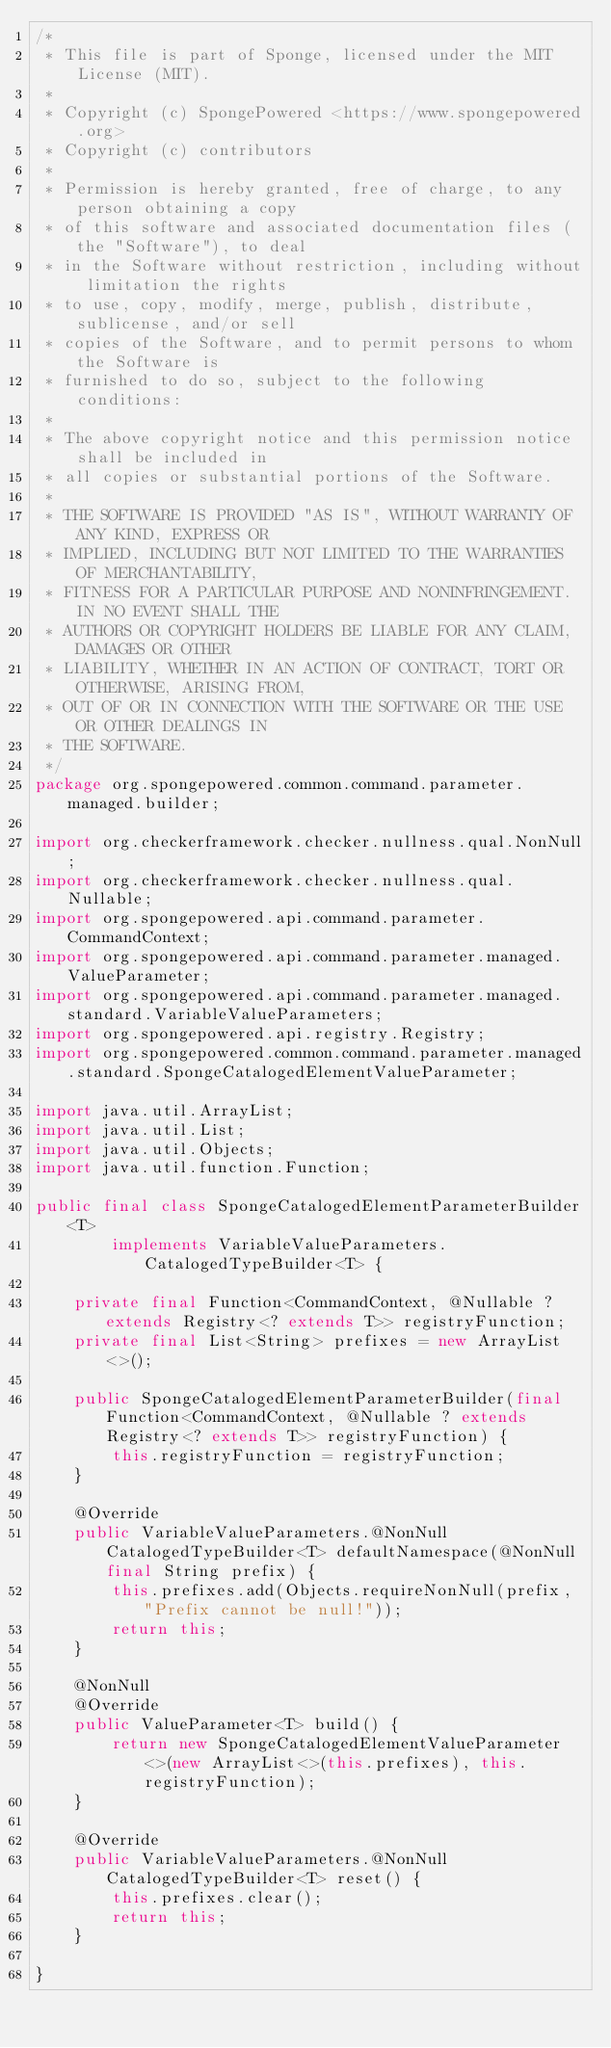<code> <loc_0><loc_0><loc_500><loc_500><_Java_>/*
 * This file is part of Sponge, licensed under the MIT License (MIT).
 *
 * Copyright (c) SpongePowered <https://www.spongepowered.org>
 * Copyright (c) contributors
 *
 * Permission is hereby granted, free of charge, to any person obtaining a copy
 * of this software and associated documentation files (the "Software"), to deal
 * in the Software without restriction, including without limitation the rights
 * to use, copy, modify, merge, publish, distribute, sublicense, and/or sell
 * copies of the Software, and to permit persons to whom the Software is
 * furnished to do so, subject to the following conditions:
 *
 * The above copyright notice and this permission notice shall be included in
 * all copies or substantial portions of the Software.
 *
 * THE SOFTWARE IS PROVIDED "AS IS", WITHOUT WARRANTY OF ANY KIND, EXPRESS OR
 * IMPLIED, INCLUDING BUT NOT LIMITED TO THE WARRANTIES OF MERCHANTABILITY,
 * FITNESS FOR A PARTICULAR PURPOSE AND NONINFRINGEMENT. IN NO EVENT SHALL THE
 * AUTHORS OR COPYRIGHT HOLDERS BE LIABLE FOR ANY CLAIM, DAMAGES OR OTHER
 * LIABILITY, WHETHER IN AN ACTION OF CONTRACT, TORT OR OTHERWISE, ARISING FROM,
 * OUT OF OR IN CONNECTION WITH THE SOFTWARE OR THE USE OR OTHER DEALINGS IN
 * THE SOFTWARE.
 */
package org.spongepowered.common.command.parameter.managed.builder;

import org.checkerframework.checker.nullness.qual.NonNull;
import org.checkerframework.checker.nullness.qual.Nullable;
import org.spongepowered.api.command.parameter.CommandContext;
import org.spongepowered.api.command.parameter.managed.ValueParameter;
import org.spongepowered.api.command.parameter.managed.standard.VariableValueParameters;
import org.spongepowered.api.registry.Registry;
import org.spongepowered.common.command.parameter.managed.standard.SpongeCatalogedElementValueParameter;

import java.util.ArrayList;
import java.util.List;
import java.util.Objects;
import java.util.function.Function;

public final class SpongeCatalogedElementParameterBuilder<T>
        implements VariableValueParameters.CatalogedTypeBuilder<T> {

    private final Function<CommandContext, @Nullable ? extends Registry<? extends T>> registryFunction;
    private final List<String> prefixes = new ArrayList<>();

    public SpongeCatalogedElementParameterBuilder(final Function<CommandContext, @Nullable ? extends Registry<? extends T>> registryFunction) {
        this.registryFunction = registryFunction;
    }

    @Override
    public VariableValueParameters.@NonNull CatalogedTypeBuilder<T> defaultNamespace(@NonNull final String prefix) {
        this.prefixes.add(Objects.requireNonNull(prefix, "Prefix cannot be null!"));
        return this;
    }

    @NonNull
    @Override
    public ValueParameter<T> build() {
        return new SpongeCatalogedElementValueParameter<>(new ArrayList<>(this.prefixes), this.registryFunction);
    }

    @Override
    public VariableValueParameters.@NonNull CatalogedTypeBuilder<T> reset() {
        this.prefixes.clear();
        return this;
    }

}
</code> 